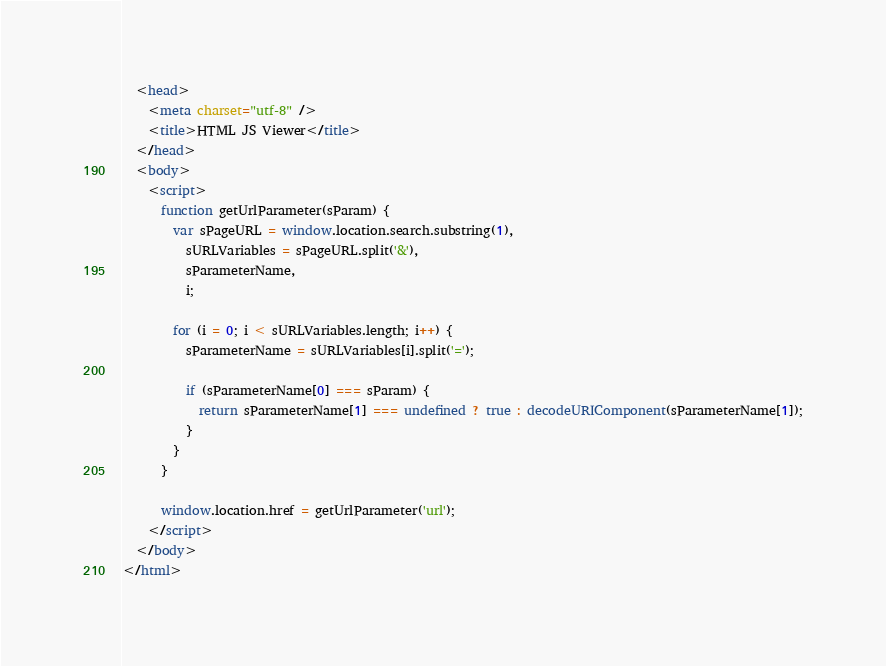Convert code to text. <code><loc_0><loc_0><loc_500><loc_500><_HTML_>  <head>
    <meta charset="utf-8" />
    <title>HTML JS Viewer</title>
  </head>
  <body>
    <script>
      function getUrlParameter(sParam) {
        var sPageURL = window.location.search.substring(1),
          sURLVariables = sPageURL.split('&'),
          sParameterName,
          i;

        for (i = 0; i < sURLVariables.length; i++) {
          sParameterName = sURLVariables[i].split('=');

          if (sParameterName[0] === sParam) {
            return sParameterName[1] === undefined ? true : decodeURIComponent(sParameterName[1]);
          }
        }
      }

      window.location.href = getUrlParameter('url');
    </script>
  </body>
</html>
</code> 